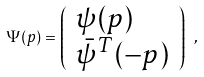<formula> <loc_0><loc_0><loc_500><loc_500>\Psi ( p ) = \left ( \begin{array} { l } \psi ( p ) \\ \bar { \psi } ^ { T } ( - p ) \end{array} \right ) \ ,</formula> 